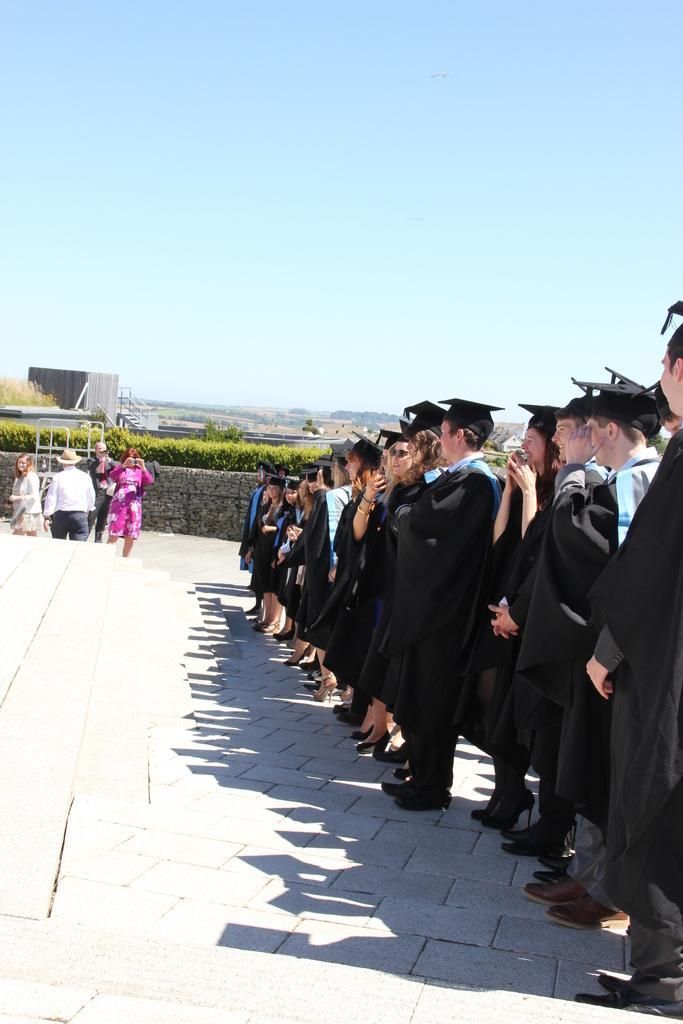In one or two sentences, can you explain what this image depicts? As we can see in the image there are group of people here and there, plants, building and sky. 